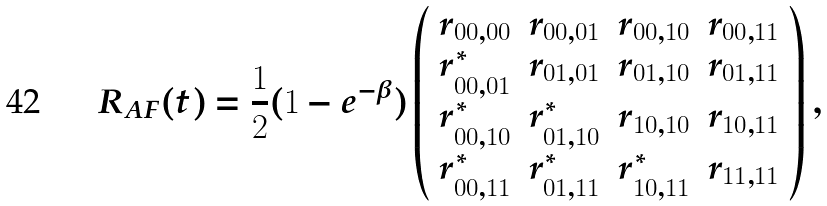<formula> <loc_0><loc_0><loc_500><loc_500>R _ { A F } ( t ) = \frac { 1 } { 2 } ( 1 - e ^ { - \beta } ) \left ( \begin{array} { c c c c } r _ { 0 0 , 0 0 } & r _ { 0 0 , 0 1 } & r _ { 0 0 , 1 0 } & r _ { 0 0 , 1 1 } \\ r _ { 0 0 , 0 1 } ^ { \ast } & r _ { 0 1 , 0 1 } & r _ { 0 1 , 1 0 } & r _ { 0 1 , 1 1 } \\ r _ { 0 0 , 1 0 } ^ { \ast } & r _ { 0 1 , 1 0 } ^ { \ast } & r _ { 1 0 , 1 0 } & r _ { 1 0 , 1 1 } \\ r _ { 0 0 , 1 1 } ^ { \ast } & r _ { 0 1 , 1 1 } ^ { \ast } & r _ { 1 0 , 1 1 } ^ { \ast } & r _ { 1 1 , 1 1 } \end{array} \right ) ,</formula> 